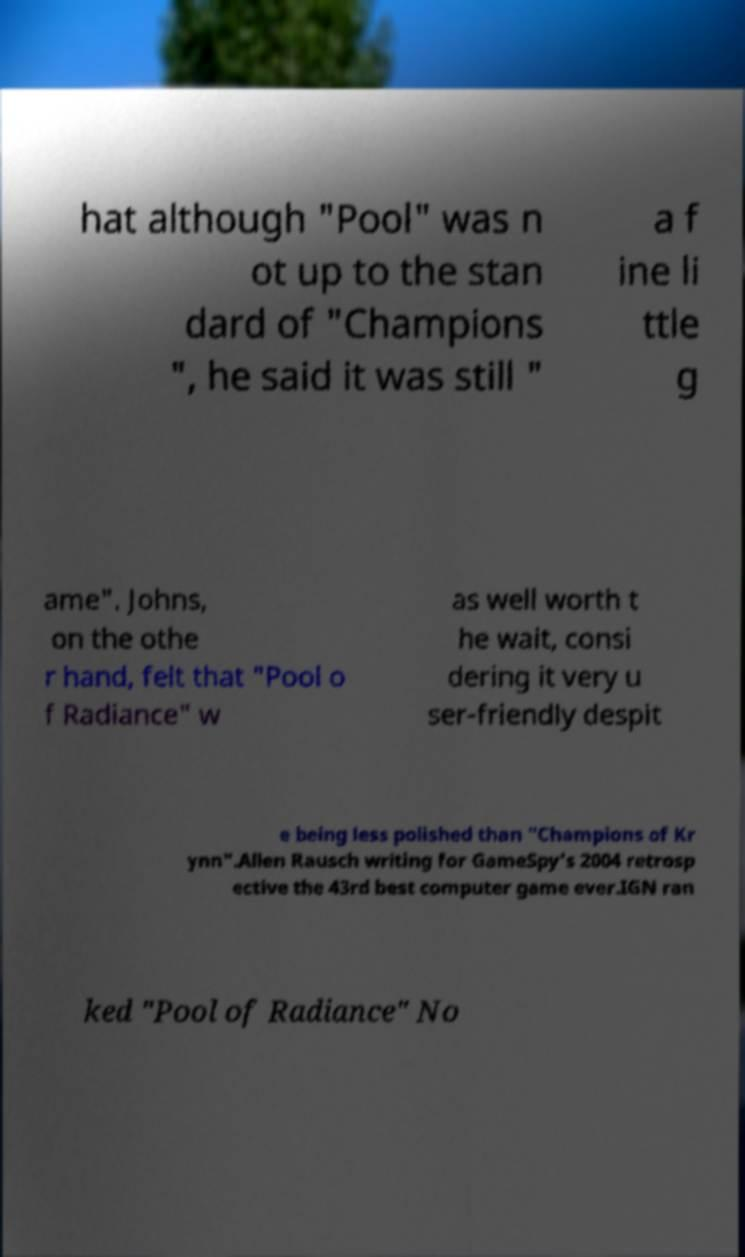I need the written content from this picture converted into text. Can you do that? hat although "Pool" was n ot up to the stan dard of "Champions ", he said it was still " a f ine li ttle g ame". Johns, on the othe r hand, felt that "Pool o f Radiance" w as well worth t he wait, consi dering it very u ser-friendly despit e being less polished than "Champions of Kr ynn".Allen Rausch writing for GameSpy's 2004 retrosp ective the 43rd best computer game ever.IGN ran ked "Pool of Radiance" No 